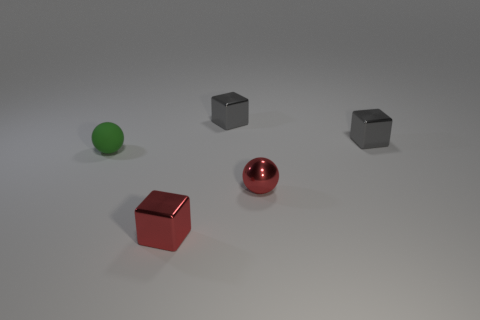How many yellow objects are metal balls or metallic objects?
Your answer should be very brief. 0. What is the size of the red block that is made of the same material as the red sphere?
Ensure brevity in your answer.  Small. Is the tiny gray block that is on the right side of the tiny red metallic sphere made of the same material as the sphere to the right of the green sphere?
Make the answer very short. Yes. What number of cylinders are big cyan shiny things or gray metallic objects?
Make the answer very short. 0. How many tiny rubber spheres are behind the small red shiny thing behind the small block that is in front of the small green rubber thing?
Keep it short and to the point. 1. What is the material of the small red thing that is the same shape as the small green rubber thing?
Offer a very short reply. Metal. Is there anything else that has the same material as the green sphere?
Offer a very short reply. No. There is a sphere right of the small matte object; what is its color?
Offer a very short reply. Red. Is the material of the small green object the same as the small cube in front of the tiny green sphere?
Keep it short and to the point. No. What is the small green thing made of?
Keep it short and to the point. Rubber. 